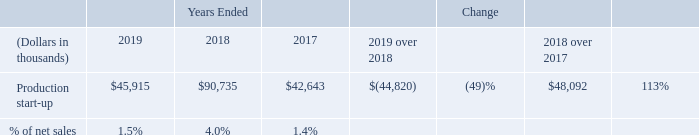Production start-up
Production start-up expense consists primarily of employee compensation and other costs associated with operating a production line before it is qualified for full production, including the cost of raw materials for solar modules run through the production line during the qualification phase and applicable facility related costs. Costs related to equipment upgrades and implementation of manufacturing process improvements are also included in production start-up expense as well as costs related to the selection of a new site, related legal and regulatory costs, and costs to maintain our plant replication program to the extent we cannot capitalize these expenditures. In general, we expect production start-up expense per production line to be higher when we build an entirely new manufacturing facility compared with the addition or replacement of production lines at an existing manufacturing facility, primarily due to the additional infrastructure investment required when building an entirely new facility.
The following table shows production start-up expense for the years ended December 31, 2019, 2018, and 2017:
During 2019, we incurred production start-up expense at our new facility in Lake Township, Ohio. We also incurred production start-up expense at our second facility in Ho Chi Minh City, Vietnam in early 2019. During 2018, we incurred production start-up expense for the transition to Series 6 module manufacturing at our facilities in Kulim, Malaysia and Ho Chi Minh City, Vietnam. We also incurred production start-up expense for the transition to Series 6 module manufacturing at our facility in Perrysburg, Ohio in early 2018.
What are components of production start-up expense? Production start-up expense consists primarily of employee compensation and other costs associated with operating a production line before it is qualified for full production, including the cost of raw materials for solar modules run through the production line during the qualification phase and applicable facility related costs. When will production start-up expense be higher? In general, we expect production start-up expense per production line to be higher when we build an entirely new manufacturing facility compared with the addition or replacement of production lines at an existing manufacturing facility, primarily due to the additional infrastructure investment required when building an entirely new facility. Where are production start-up expense incurred in 2019? During 2019, we incurred production start-up expense at our new facility in lake township, ohio. we also incurred production start-up expense at our second facility in ho chi minh city, vietnam in early 2019. What is the net difference in production start-up expense between 2019 and 2017?
Answer scale should be: thousand. 45,915 - 42,643 
Answer: 3272. What is the amount of net sales derived in 2018?
Answer scale should be: thousand. 90,735 / 4% 
Answer: 2268375. What is the difference in net sales amount in 2019 and 2018?
Answer scale should be: thousand. (45,915 / 1.5%) - (90,735 / 4%) 
Answer: 792625. 